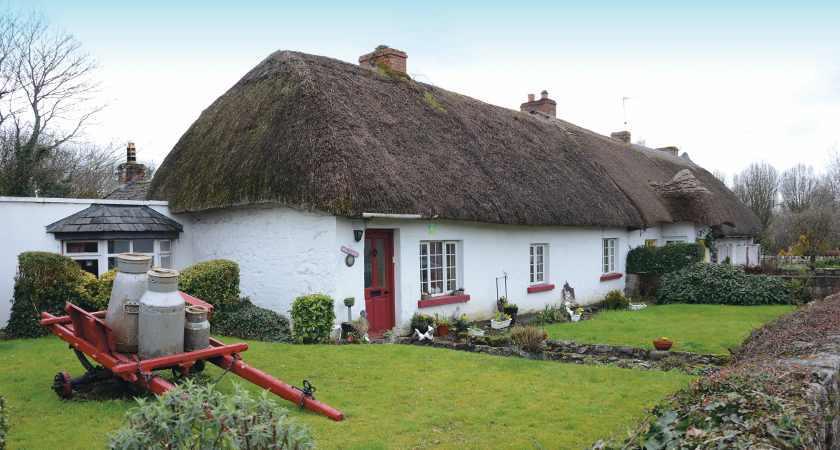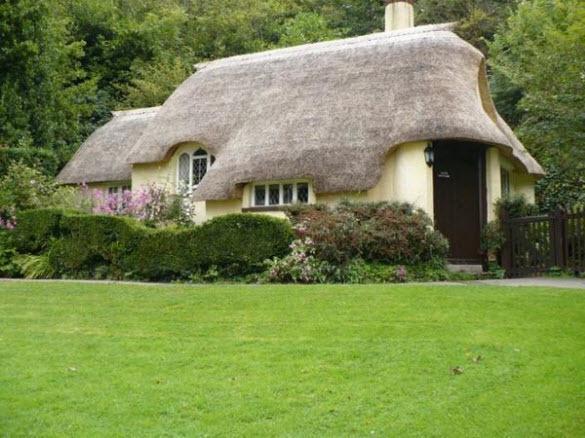The first image is the image on the left, the second image is the image on the right. For the images displayed, is the sentence "In at least one image there is a small outside shed with hay for the roof and wood for the sides." factually correct? Answer yes or no. No. The first image is the image on the left, the second image is the image on the right. Considering the images on both sides, is "The right image shows a simple square structure with a sloping shaggy thatched roof that has a flat ridge on top, sitting on a green field with no landscaping around it." valid? Answer yes or no. No. 